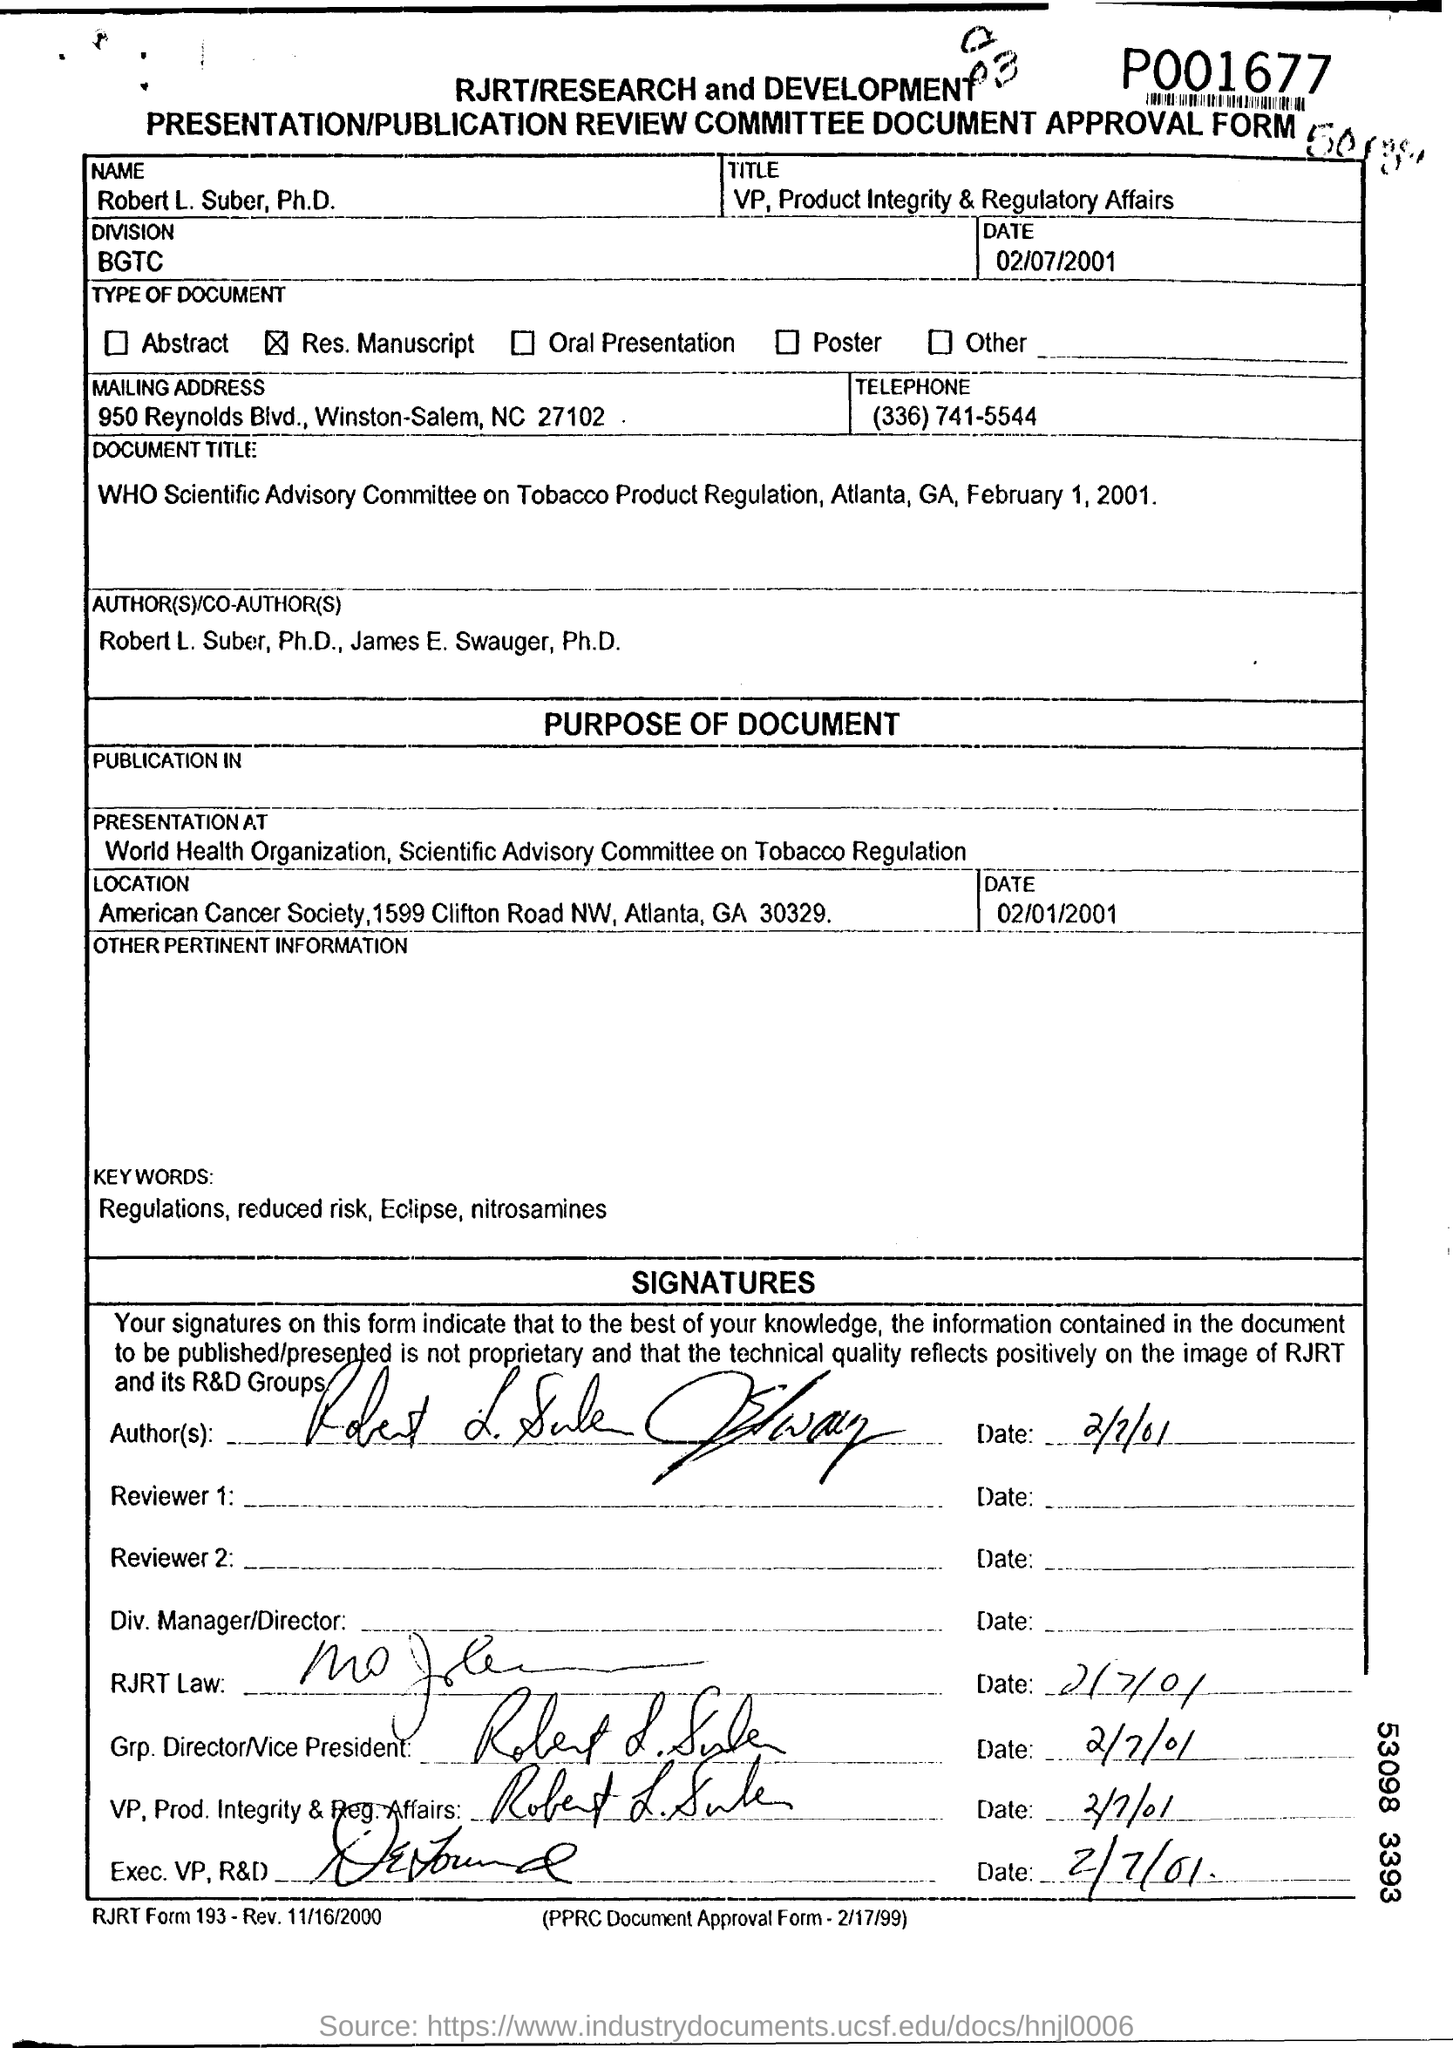What name is written in the Approval Form ?
Your response must be concise. Robert L. Suber, Ph.D. What is the title of Robert L. Suber?
Offer a very short reply. VP, Product Integrity & Regulatory Affairs. What is the date mentioned in the top of the document ?
Your answer should be compact. 02/07/2001. What is Written in the Division Field ?
Make the answer very short. BGTC. What is the Telephone Number ?
Your answer should be very brief. (336) 741-5544. 